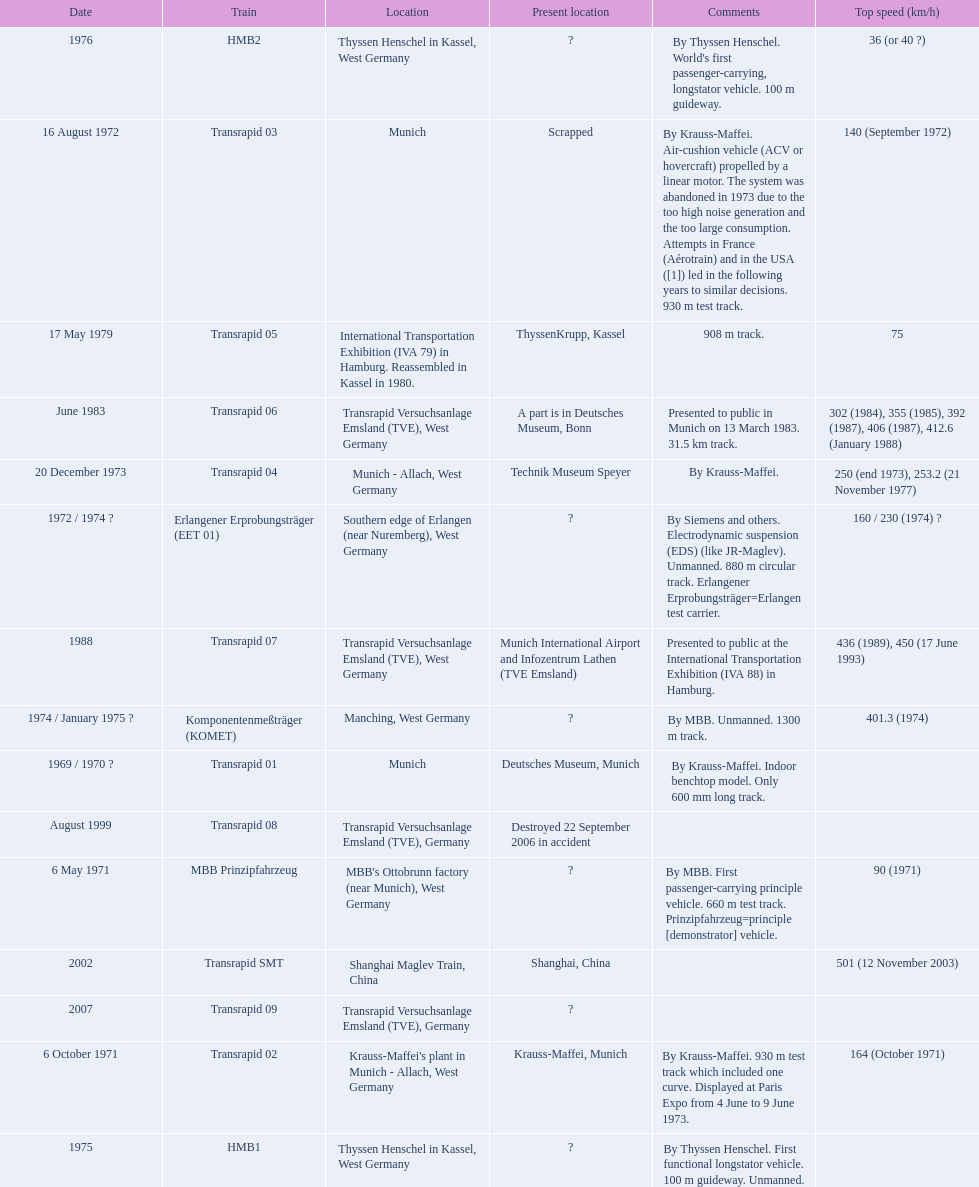What is the top speed reached by any trains shown here? 501 (12 November 2003). What train has reached a top speed of 501? Transrapid SMT. 